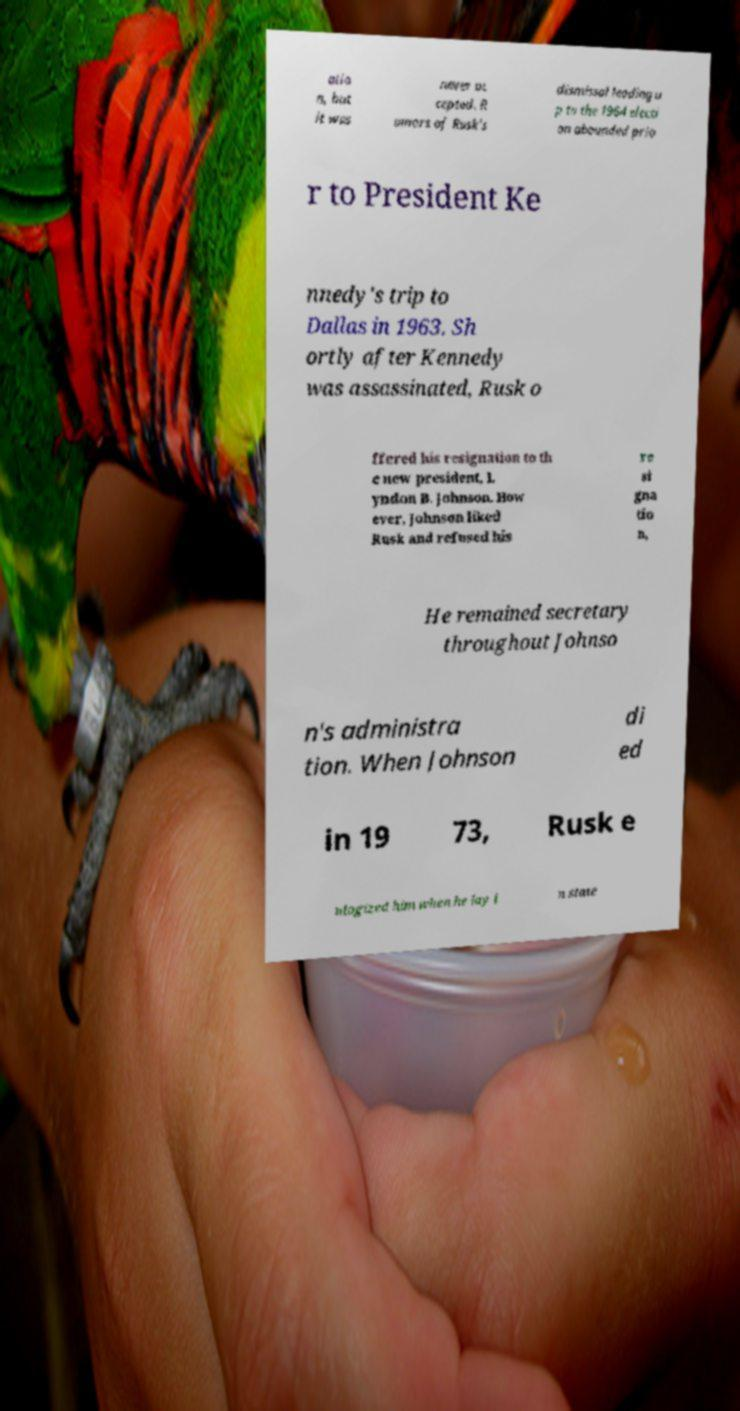There's text embedded in this image that I need extracted. Can you transcribe it verbatim? atio n, but it was never ac cepted. R umors of Rusk's dismissal leading u p to the 1964 electi on abounded prio r to President Ke nnedy's trip to Dallas in 1963. Sh ortly after Kennedy was assassinated, Rusk o ffered his resignation to th e new president, L yndon B. Johnson. How ever, Johnson liked Rusk and refused his re si gna tio n, He remained secretary throughout Johnso n's administra tion. When Johnson di ed in 19 73, Rusk e ulogized him when he lay i n state 